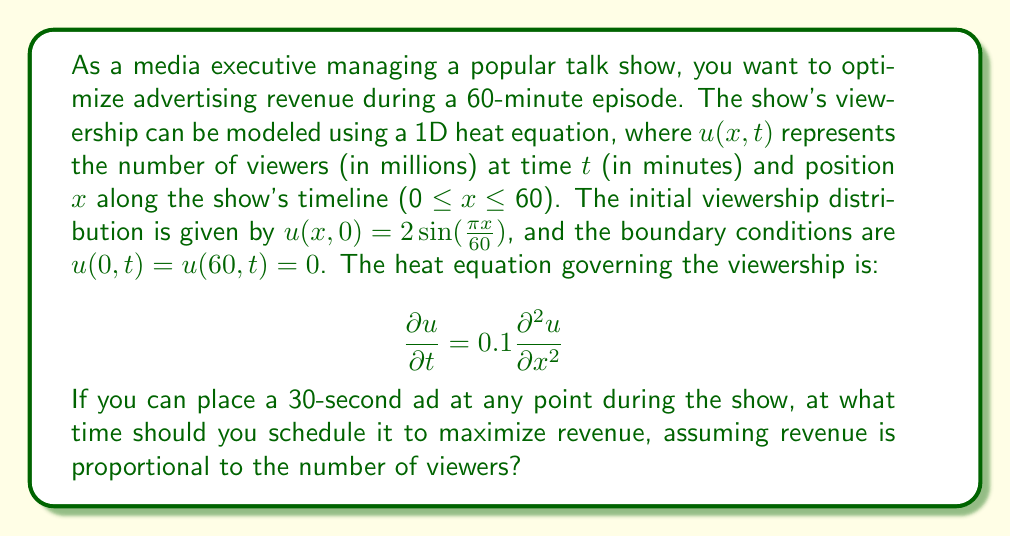Provide a solution to this math problem. To solve this problem, we need to find the maximum viewership during the show. The solution to the 1D heat equation with the given initial and boundary conditions is:

$$u(x,t) = 2\sin(\frac{\pi x}{60})e^{-0.1(\frac{\pi}{60})^2t}$$

To find the maximum viewership, we need to determine the critical points of $u(x,t)$ with respect to $x$ and $t$.

1. First, let's find $\frac{\partial u}{\partial x}$:
   $$\frac{\partial u}{\partial x} = \frac{\pi}{30}\cos(\frac{\pi x}{60})e^{-0.1(\frac{\pi}{60})^2t}$$

2. Set $\frac{\partial u}{\partial x} = 0$ to find critical points in $x$:
   $$\frac{\pi}{30}\cos(\frac{\pi x}{60})e^{-0.1(\frac{\pi}{60})^2t} = 0$$
   This is satisfied when $\cos(\frac{\pi x}{60}) = 0$, which occurs at $x = 30$ minutes.

3. Now, let's find $\frac{\partial u}{\partial t}$:
   $$\frac{\partial u}{\partial t} = -0.1(\frac{\pi}{60})^2 \cdot 2\sin(\frac{\pi x}{60})e^{-0.1(\frac{\pi}{60})^2t}$$

4. Set $\frac{\partial u}{\partial t} = 0$:
   $$-0.1(\frac{\pi}{60})^2 \cdot 2\sin(\frac{\pi x}{60})e^{-0.1(\frac{\pi}{60})^2t} = 0$$
   This is satisfied when $t = 0$ or $\sin(\frac{\pi x}{60}) = 0$. However, $\sin(\frac{\pi x}{60}) = 0$ only occurs at the boundaries where viewership is zero, so we focus on $t = 0$.

5. Combining the results, we find that the maximum viewership occurs at $x = 30$ minutes and $t = 0$ minutes.

Therefore, to maximize revenue, you should schedule the 30-second ad at the 30-minute mark of the show, which corresponds to the midpoint of the episode.
Answer: The optimal time to schedule the 30-second ad is at the 30-minute mark of the show. 